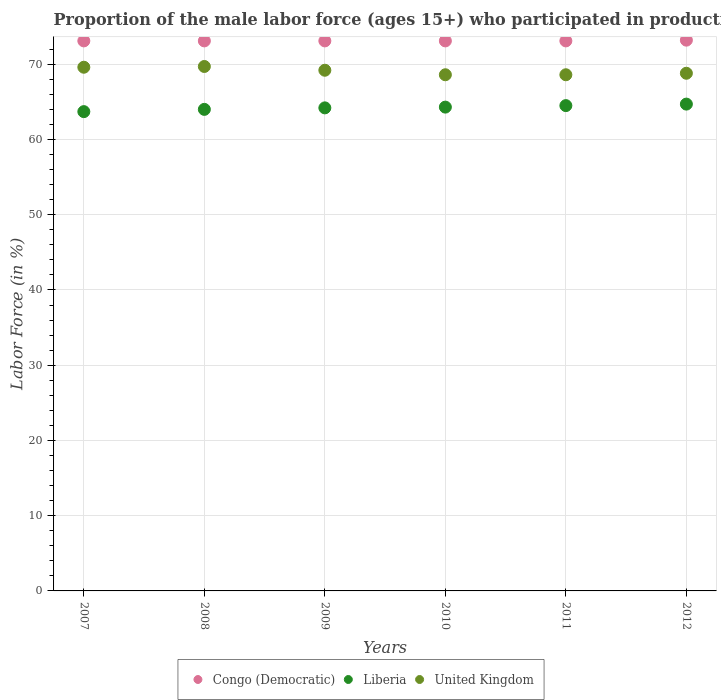How many different coloured dotlines are there?
Provide a short and direct response. 3. Is the number of dotlines equal to the number of legend labels?
Provide a succinct answer. Yes. What is the proportion of the male labor force who participated in production in Liberia in 2011?
Keep it short and to the point. 64.5. Across all years, what is the maximum proportion of the male labor force who participated in production in Liberia?
Your answer should be very brief. 64.7. Across all years, what is the minimum proportion of the male labor force who participated in production in United Kingdom?
Provide a short and direct response. 68.6. In which year was the proportion of the male labor force who participated in production in Congo (Democratic) maximum?
Ensure brevity in your answer.  2012. In which year was the proportion of the male labor force who participated in production in United Kingdom minimum?
Your answer should be compact. 2010. What is the total proportion of the male labor force who participated in production in Liberia in the graph?
Make the answer very short. 385.4. What is the difference between the proportion of the male labor force who participated in production in United Kingdom in 2007 and that in 2011?
Offer a very short reply. 1. What is the difference between the proportion of the male labor force who participated in production in Congo (Democratic) in 2007 and the proportion of the male labor force who participated in production in United Kingdom in 2012?
Ensure brevity in your answer.  4.3. What is the average proportion of the male labor force who participated in production in United Kingdom per year?
Offer a terse response. 69.08. In the year 2010, what is the difference between the proportion of the male labor force who participated in production in United Kingdom and proportion of the male labor force who participated in production in Liberia?
Make the answer very short. 4.3. In how many years, is the proportion of the male labor force who participated in production in Congo (Democratic) greater than 60 %?
Offer a very short reply. 6. What is the ratio of the proportion of the male labor force who participated in production in Congo (Democratic) in 2008 to that in 2012?
Your answer should be compact. 1. Is the proportion of the male labor force who participated in production in Congo (Democratic) in 2007 less than that in 2009?
Ensure brevity in your answer.  No. Is the difference between the proportion of the male labor force who participated in production in United Kingdom in 2009 and 2011 greater than the difference between the proportion of the male labor force who participated in production in Liberia in 2009 and 2011?
Make the answer very short. Yes. What is the difference between the highest and the second highest proportion of the male labor force who participated in production in Congo (Democratic)?
Make the answer very short. 0.1. What is the difference between the highest and the lowest proportion of the male labor force who participated in production in Liberia?
Offer a terse response. 1. In how many years, is the proportion of the male labor force who participated in production in United Kingdom greater than the average proportion of the male labor force who participated in production in United Kingdom taken over all years?
Your answer should be very brief. 3. Is the sum of the proportion of the male labor force who participated in production in Liberia in 2008 and 2011 greater than the maximum proportion of the male labor force who participated in production in United Kingdom across all years?
Provide a succinct answer. Yes. Is it the case that in every year, the sum of the proportion of the male labor force who participated in production in United Kingdom and proportion of the male labor force who participated in production in Congo (Democratic)  is greater than the proportion of the male labor force who participated in production in Liberia?
Offer a very short reply. Yes. Is the proportion of the male labor force who participated in production in Liberia strictly greater than the proportion of the male labor force who participated in production in Congo (Democratic) over the years?
Your answer should be very brief. No. Is the proportion of the male labor force who participated in production in Liberia strictly less than the proportion of the male labor force who participated in production in Congo (Democratic) over the years?
Provide a short and direct response. Yes. How many years are there in the graph?
Provide a succinct answer. 6. What is the difference between two consecutive major ticks on the Y-axis?
Your response must be concise. 10. Are the values on the major ticks of Y-axis written in scientific E-notation?
Provide a succinct answer. No. Does the graph contain grids?
Your response must be concise. Yes. Where does the legend appear in the graph?
Your answer should be compact. Bottom center. How are the legend labels stacked?
Provide a short and direct response. Horizontal. What is the title of the graph?
Ensure brevity in your answer.  Proportion of the male labor force (ages 15+) who participated in production. Does "Timor-Leste" appear as one of the legend labels in the graph?
Ensure brevity in your answer.  No. What is the Labor Force (in %) in Congo (Democratic) in 2007?
Make the answer very short. 73.1. What is the Labor Force (in %) of Liberia in 2007?
Ensure brevity in your answer.  63.7. What is the Labor Force (in %) in United Kingdom in 2007?
Give a very brief answer. 69.6. What is the Labor Force (in %) of Congo (Democratic) in 2008?
Give a very brief answer. 73.1. What is the Labor Force (in %) in United Kingdom in 2008?
Your response must be concise. 69.7. What is the Labor Force (in %) of Congo (Democratic) in 2009?
Provide a short and direct response. 73.1. What is the Labor Force (in %) in Liberia in 2009?
Make the answer very short. 64.2. What is the Labor Force (in %) in United Kingdom in 2009?
Provide a short and direct response. 69.2. What is the Labor Force (in %) in Congo (Democratic) in 2010?
Your response must be concise. 73.1. What is the Labor Force (in %) in Liberia in 2010?
Your answer should be very brief. 64.3. What is the Labor Force (in %) in United Kingdom in 2010?
Provide a short and direct response. 68.6. What is the Labor Force (in %) in Congo (Democratic) in 2011?
Offer a very short reply. 73.1. What is the Labor Force (in %) in Liberia in 2011?
Provide a succinct answer. 64.5. What is the Labor Force (in %) of United Kingdom in 2011?
Provide a short and direct response. 68.6. What is the Labor Force (in %) of Congo (Democratic) in 2012?
Your response must be concise. 73.2. What is the Labor Force (in %) of Liberia in 2012?
Your answer should be compact. 64.7. What is the Labor Force (in %) in United Kingdom in 2012?
Your answer should be very brief. 68.8. Across all years, what is the maximum Labor Force (in %) in Congo (Democratic)?
Ensure brevity in your answer.  73.2. Across all years, what is the maximum Labor Force (in %) in Liberia?
Provide a succinct answer. 64.7. Across all years, what is the maximum Labor Force (in %) of United Kingdom?
Your answer should be very brief. 69.7. Across all years, what is the minimum Labor Force (in %) of Congo (Democratic)?
Give a very brief answer. 73.1. Across all years, what is the minimum Labor Force (in %) of Liberia?
Your answer should be compact. 63.7. Across all years, what is the minimum Labor Force (in %) of United Kingdom?
Your response must be concise. 68.6. What is the total Labor Force (in %) of Congo (Democratic) in the graph?
Give a very brief answer. 438.7. What is the total Labor Force (in %) of Liberia in the graph?
Provide a succinct answer. 385.4. What is the total Labor Force (in %) in United Kingdom in the graph?
Keep it short and to the point. 414.5. What is the difference between the Labor Force (in %) in Liberia in 2007 and that in 2008?
Your answer should be compact. -0.3. What is the difference between the Labor Force (in %) of Congo (Democratic) in 2007 and that in 2009?
Give a very brief answer. 0. What is the difference between the Labor Force (in %) of Liberia in 2007 and that in 2009?
Make the answer very short. -0.5. What is the difference between the Labor Force (in %) of Liberia in 2007 and that in 2011?
Your answer should be compact. -0.8. What is the difference between the Labor Force (in %) in Congo (Democratic) in 2007 and that in 2012?
Offer a very short reply. -0.1. What is the difference between the Labor Force (in %) in Congo (Democratic) in 2008 and that in 2009?
Provide a short and direct response. 0. What is the difference between the Labor Force (in %) in United Kingdom in 2008 and that in 2009?
Provide a short and direct response. 0.5. What is the difference between the Labor Force (in %) in Congo (Democratic) in 2008 and that in 2010?
Your answer should be compact. 0. What is the difference between the Labor Force (in %) in Liberia in 2008 and that in 2011?
Offer a terse response. -0.5. What is the difference between the Labor Force (in %) of United Kingdom in 2008 and that in 2011?
Offer a very short reply. 1.1. What is the difference between the Labor Force (in %) of Liberia in 2008 and that in 2012?
Keep it short and to the point. -0.7. What is the difference between the Labor Force (in %) in Congo (Democratic) in 2009 and that in 2010?
Make the answer very short. 0. What is the difference between the Labor Force (in %) in Liberia in 2009 and that in 2010?
Your response must be concise. -0.1. What is the difference between the Labor Force (in %) of Congo (Democratic) in 2009 and that in 2011?
Make the answer very short. 0. What is the difference between the Labor Force (in %) in Liberia in 2009 and that in 2011?
Offer a terse response. -0.3. What is the difference between the Labor Force (in %) of Liberia in 2009 and that in 2012?
Give a very brief answer. -0.5. What is the difference between the Labor Force (in %) of United Kingdom in 2009 and that in 2012?
Your response must be concise. 0.4. What is the difference between the Labor Force (in %) in Congo (Democratic) in 2010 and that in 2011?
Ensure brevity in your answer.  0. What is the difference between the Labor Force (in %) of Liberia in 2010 and that in 2011?
Provide a succinct answer. -0.2. What is the difference between the Labor Force (in %) in United Kingdom in 2010 and that in 2011?
Make the answer very short. 0. What is the difference between the Labor Force (in %) in Congo (Democratic) in 2010 and that in 2012?
Your answer should be very brief. -0.1. What is the difference between the Labor Force (in %) of Congo (Democratic) in 2007 and the Labor Force (in %) of Liberia in 2008?
Give a very brief answer. 9.1. What is the difference between the Labor Force (in %) of Congo (Democratic) in 2007 and the Labor Force (in %) of United Kingdom in 2008?
Provide a succinct answer. 3.4. What is the difference between the Labor Force (in %) in Liberia in 2007 and the Labor Force (in %) in United Kingdom in 2008?
Your answer should be compact. -6. What is the difference between the Labor Force (in %) of Congo (Democratic) in 2007 and the Labor Force (in %) of Liberia in 2009?
Offer a very short reply. 8.9. What is the difference between the Labor Force (in %) in Congo (Democratic) in 2007 and the Labor Force (in %) in United Kingdom in 2009?
Ensure brevity in your answer.  3.9. What is the difference between the Labor Force (in %) in Congo (Democratic) in 2007 and the Labor Force (in %) in Liberia in 2010?
Make the answer very short. 8.8. What is the difference between the Labor Force (in %) of Congo (Democratic) in 2007 and the Labor Force (in %) of United Kingdom in 2010?
Ensure brevity in your answer.  4.5. What is the difference between the Labor Force (in %) of Congo (Democratic) in 2007 and the Labor Force (in %) of Liberia in 2011?
Offer a terse response. 8.6. What is the difference between the Labor Force (in %) in Liberia in 2007 and the Labor Force (in %) in United Kingdom in 2011?
Provide a short and direct response. -4.9. What is the difference between the Labor Force (in %) in Congo (Democratic) in 2007 and the Labor Force (in %) in Liberia in 2012?
Ensure brevity in your answer.  8.4. What is the difference between the Labor Force (in %) in Congo (Democratic) in 2007 and the Labor Force (in %) in United Kingdom in 2012?
Your answer should be compact. 4.3. What is the difference between the Labor Force (in %) in Congo (Democratic) in 2008 and the Labor Force (in %) in United Kingdom in 2009?
Your answer should be compact. 3.9. What is the difference between the Labor Force (in %) of Liberia in 2008 and the Labor Force (in %) of United Kingdom in 2009?
Your response must be concise. -5.2. What is the difference between the Labor Force (in %) of Congo (Democratic) in 2008 and the Labor Force (in %) of Liberia in 2010?
Your response must be concise. 8.8. What is the difference between the Labor Force (in %) in Liberia in 2008 and the Labor Force (in %) in United Kingdom in 2010?
Offer a very short reply. -4.6. What is the difference between the Labor Force (in %) of Congo (Democratic) in 2009 and the Labor Force (in %) of United Kingdom in 2011?
Offer a very short reply. 4.5. What is the difference between the Labor Force (in %) in Congo (Democratic) in 2009 and the Labor Force (in %) in Liberia in 2012?
Your answer should be compact. 8.4. What is the difference between the Labor Force (in %) in Congo (Democratic) in 2009 and the Labor Force (in %) in United Kingdom in 2012?
Provide a short and direct response. 4.3. What is the difference between the Labor Force (in %) in Congo (Democratic) in 2010 and the Labor Force (in %) in United Kingdom in 2011?
Provide a succinct answer. 4.5. What is the difference between the Labor Force (in %) of Congo (Democratic) in 2010 and the Labor Force (in %) of Liberia in 2012?
Keep it short and to the point. 8.4. What is the difference between the Labor Force (in %) in Congo (Democratic) in 2010 and the Labor Force (in %) in United Kingdom in 2012?
Keep it short and to the point. 4.3. What is the difference between the Labor Force (in %) of Congo (Democratic) in 2011 and the Labor Force (in %) of Liberia in 2012?
Offer a terse response. 8.4. What is the difference between the Labor Force (in %) in Congo (Democratic) in 2011 and the Labor Force (in %) in United Kingdom in 2012?
Make the answer very short. 4.3. What is the average Labor Force (in %) in Congo (Democratic) per year?
Your answer should be very brief. 73.12. What is the average Labor Force (in %) in Liberia per year?
Give a very brief answer. 64.23. What is the average Labor Force (in %) of United Kingdom per year?
Provide a short and direct response. 69.08. In the year 2007, what is the difference between the Labor Force (in %) in Congo (Democratic) and Labor Force (in %) in Liberia?
Your answer should be very brief. 9.4. In the year 2008, what is the difference between the Labor Force (in %) of Congo (Democratic) and Labor Force (in %) of Liberia?
Ensure brevity in your answer.  9.1. In the year 2009, what is the difference between the Labor Force (in %) in Liberia and Labor Force (in %) in United Kingdom?
Offer a very short reply. -5. In the year 2010, what is the difference between the Labor Force (in %) of Congo (Democratic) and Labor Force (in %) of Liberia?
Your answer should be compact. 8.8. In the year 2011, what is the difference between the Labor Force (in %) in Congo (Democratic) and Labor Force (in %) in Liberia?
Give a very brief answer. 8.6. In the year 2011, what is the difference between the Labor Force (in %) of Congo (Democratic) and Labor Force (in %) of United Kingdom?
Provide a succinct answer. 4.5. In the year 2011, what is the difference between the Labor Force (in %) in Liberia and Labor Force (in %) in United Kingdom?
Offer a very short reply. -4.1. In the year 2012, what is the difference between the Labor Force (in %) of Congo (Democratic) and Labor Force (in %) of Liberia?
Provide a succinct answer. 8.5. In the year 2012, what is the difference between the Labor Force (in %) of Liberia and Labor Force (in %) of United Kingdom?
Offer a very short reply. -4.1. What is the ratio of the Labor Force (in %) of Congo (Democratic) in 2007 to that in 2008?
Give a very brief answer. 1. What is the ratio of the Labor Force (in %) of Liberia in 2007 to that in 2008?
Give a very brief answer. 1. What is the ratio of the Labor Force (in %) in United Kingdom in 2007 to that in 2008?
Give a very brief answer. 1. What is the ratio of the Labor Force (in %) of Congo (Democratic) in 2007 to that in 2009?
Make the answer very short. 1. What is the ratio of the Labor Force (in %) in Liberia in 2007 to that in 2009?
Your answer should be very brief. 0.99. What is the ratio of the Labor Force (in %) of United Kingdom in 2007 to that in 2009?
Keep it short and to the point. 1.01. What is the ratio of the Labor Force (in %) of Congo (Democratic) in 2007 to that in 2010?
Make the answer very short. 1. What is the ratio of the Labor Force (in %) in United Kingdom in 2007 to that in 2010?
Make the answer very short. 1.01. What is the ratio of the Labor Force (in %) of Congo (Democratic) in 2007 to that in 2011?
Keep it short and to the point. 1. What is the ratio of the Labor Force (in %) in Liberia in 2007 to that in 2011?
Provide a succinct answer. 0.99. What is the ratio of the Labor Force (in %) of United Kingdom in 2007 to that in 2011?
Your answer should be compact. 1.01. What is the ratio of the Labor Force (in %) in Congo (Democratic) in 2007 to that in 2012?
Make the answer very short. 1. What is the ratio of the Labor Force (in %) in Liberia in 2007 to that in 2012?
Your answer should be very brief. 0.98. What is the ratio of the Labor Force (in %) of United Kingdom in 2007 to that in 2012?
Your answer should be very brief. 1.01. What is the ratio of the Labor Force (in %) in Congo (Democratic) in 2008 to that in 2009?
Offer a terse response. 1. What is the ratio of the Labor Force (in %) in Liberia in 2008 to that in 2009?
Ensure brevity in your answer.  1. What is the ratio of the Labor Force (in %) in Liberia in 2008 to that in 2010?
Make the answer very short. 1. What is the ratio of the Labor Force (in %) of United Kingdom in 2008 to that in 2010?
Offer a terse response. 1.02. What is the ratio of the Labor Force (in %) in Congo (Democratic) in 2008 to that in 2012?
Ensure brevity in your answer.  1. What is the ratio of the Labor Force (in %) of Liberia in 2008 to that in 2012?
Provide a succinct answer. 0.99. What is the ratio of the Labor Force (in %) in United Kingdom in 2008 to that in 2012?
Give a very brief answer. 1.01. What is the ratio of the Labor Force (in %) of Liberia in 2009 to that in 2010?
Give a very brief answer. 1. What is the ratio of the Labor Force (in %) in United Kingdom in 2009 to that in 2010?
Provide a short and direct response. 1.01. What is the ratio of the Labor Force (in %) of Liberia in 2009 to that in 2011?
Give a very brief answer. 1. What is the ratio of the Labor Force (in %) in United Kingdom in 2009 to that in 2011?
Provide a short and direct response. 1.01. What is the ratio of the Labor Force (in %) of Congo (Democratic) in 2009 to that in 2012?
Keep it short and to the point. 1. What is the ratio of the Labor Force (in %) in United Kingdom in 2010 to that in 2012?
Provide a succinct answer. 1. What is the ratio of the Labor Force (in %) of Liberia in 2011 to that in 2012?
Offer a terse response. 1. What is the ratio of the Labor Force (in %) in United Kingdom in 2011 to that in 2012?
Your answer should be compact. 1. What is the difference between the highest and the second highest Labor Force (in %) of Congo (Democratic)?
Your response must be concise. 0.1. What is the difference between the highest and the lowest Labor Force (in %) in Liberia?
Your answer should be very brief. 1. What is the difference between the highest and the lowest Labor Force (in %) in United Kingdom?
Offer a terse response. 1.1. 